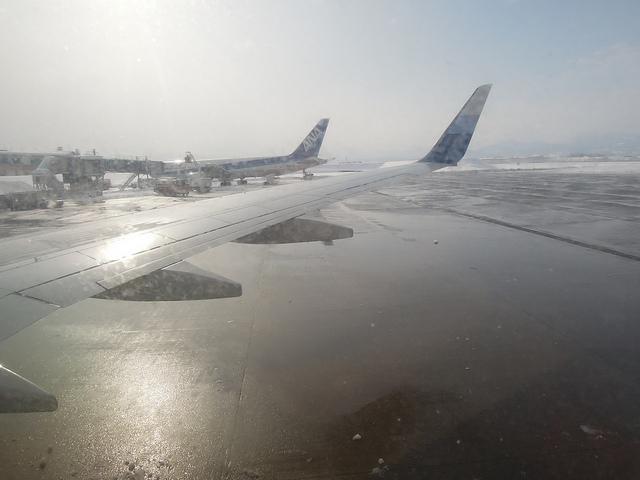How many airplanes are visible?
Give a very brief answer. 2. How many elephants are there?
Give a very brief answer. 0. 